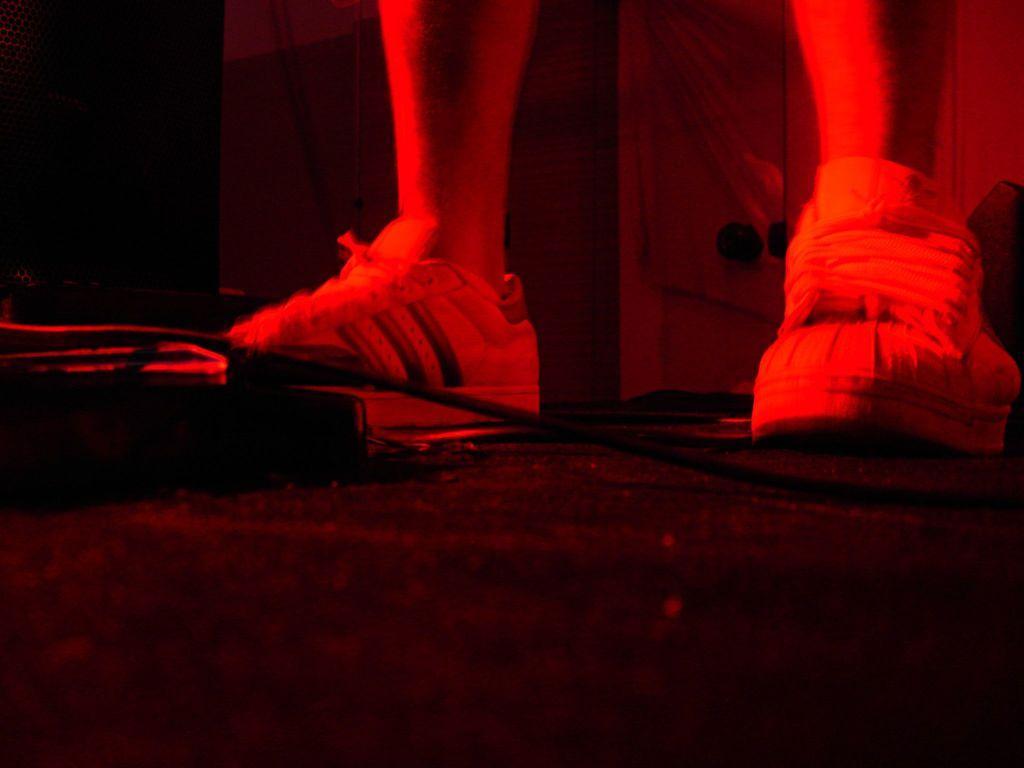Can you describe this image briefly? In this image we can see human legs on the ground. 